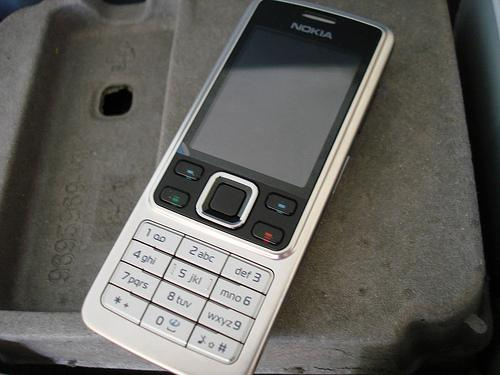Mention the logo shown on the cell phone and its position. The Nokia logo is displayed on the top of the cell phone, measuring 57 pixels wide and 57 pixels tall. Discuss the possible sentiment evoked by the image. The image might evoke a sense of nostalgia or simplicity, as it features an old Nokia cell phone turned off, without any flashy features. Please provide a description of the cell phone's screen. The cell phone has a blank screen, which is turned off and measures 196 pixels wide and 196 pixels tall. Determine the reasoning behind including a gray object in the image. The gray object serves as a contrasting background, enhancing the visual prominence of the black and silver Nokia cell phone. Provide a caption for the image focused on the cell phone. An old, black and silver Nokia cell phone with a turned-off screen, sitting on a gray object at a 45-degree angle. Analyze the interaction between the cell phone and the gray object. The Nokia cell phone is sitting on top of a gray object, positioned at a 45-degree angle, without any apparent direct interaction. Count the total number of buttons on the Nokia cell phone. There are at least 18 buttons on the Nokia cell phone, including colored buttons, power button, and numbered buttons. What is the main object in this image and specify its color? The main object is a Nokia cell phone, which is black and silver in color. Enumerate the different buttons seen on the Nokia cell phone and their corresponding colors. There are green, red, and blue buttons, as well as black power and numbered buttons on the Nokia cell phone. Assess the quality of the image based on the objects' visibility. The image quality appears to be good as the objects are clearly visible, with distinct buttons, screen, and logo on the cell phone. Is there an event happening in the image involving any of the objects? No event is happening. Is the phone screen pink in color? No, it's not mentioned in the image. Which object is made of stone? Sink Explain the main object and its features in the image. It's a Nokia cell phone with white color, blank screen, navigation buttons, number pad, and a logo on the top left corner. Describe the colors and orientation of the buttons on the Nokia cell phone. Blue, green, and red buttons surrounding the navigation button, which is silver with a black outline. Is there any visible text on the buttons in the image? Yes, there is a number printed on a button and a pound symbol. What color is the phone? White How is the cell phone positioned? In a 45 degree angle Describe the color and position of the logo lettering for the cell phone manufacturer. White color, top left corner. Choose the right color of the button from the given options: Red, Blue, Green, Black. Red, Blue, Green Mention the type of surface the cell phone is resting on. Gray Styrofoam container Explain the layout and orientation of the buttons on the cell phone. Navigation buttons at center in a circular layout, number pad below it, blue, green, and red buttons surrounding navigation buttons. Identify the text present in the image. Nokia logo and a number printed on a button Create a fictional narrative based on the objects in the image. Sara smiled as she dusted off her old white Nokia cell phone she found tucked away in a drawer, remembering the simpler times of pressing navigation buttons to send messages. What type of cell phones are visible in the image? Silver and black Nokia cell phones Provide a creative caption for the image given the objects and their colors. A sleek white Nokia cell phone with vivid navigation buttons, resting on a gray foam at a stylish angle. Describe the appearance of the sink. The sink is grey, made of stone and located in the top right corner. What object can be seen in the top right corner of the image? A sink made of stone What activity is taking place in the image involving the phone? The phone is turned off and resting on a surface. 